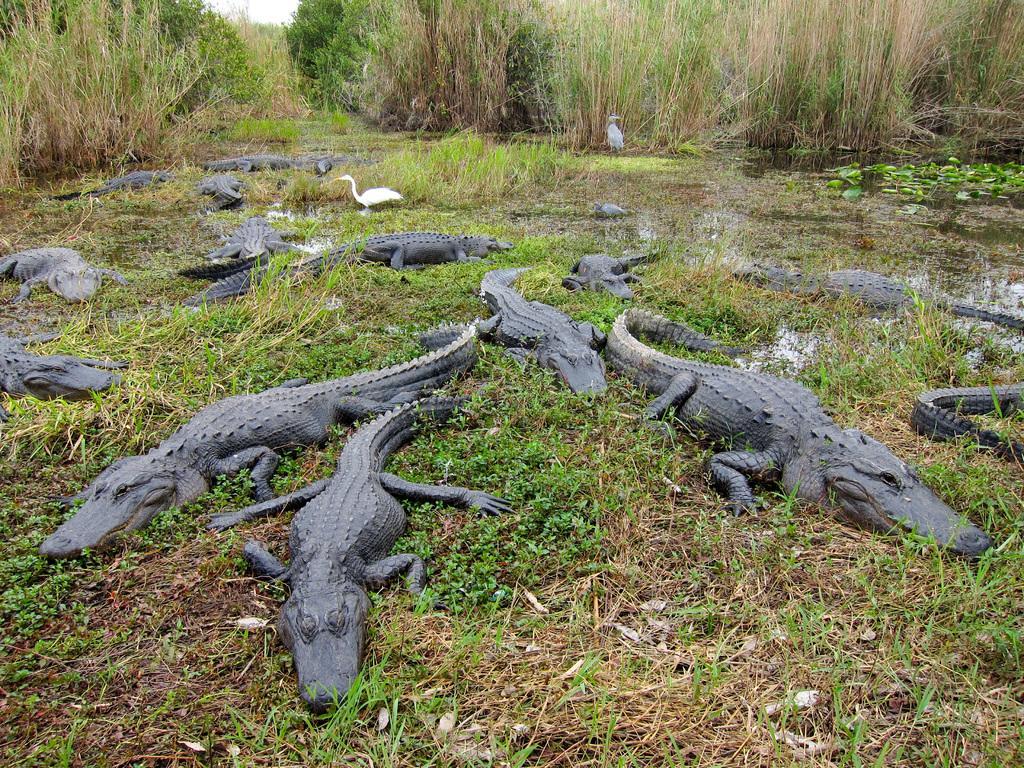Could you give a brief overview of what you see in this image? In this image we can see some crocodiles, ducks, there are plants, trees, and trees, also we can see the water and the sky. 